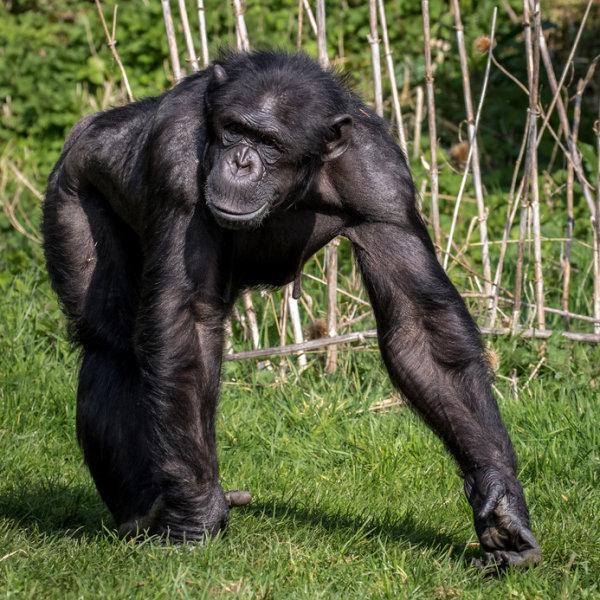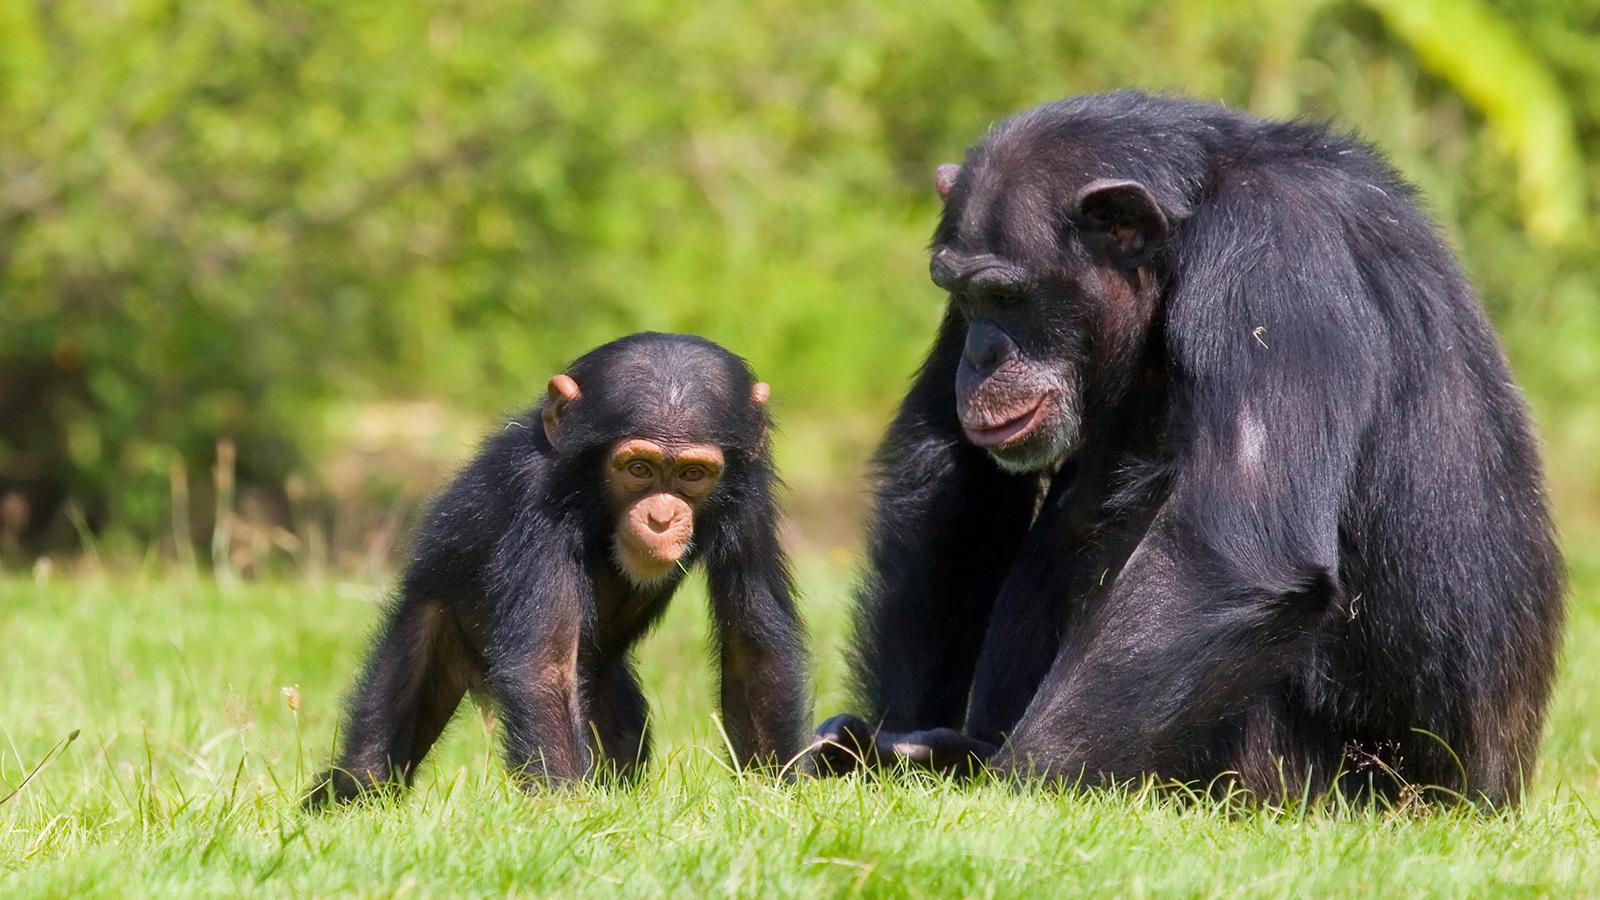The first image is the image on the left, the second image is the image on the right. For the images shown, is this caption "There are two monkeys in the image on the right." true? Answer yes or no. Yes. 